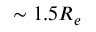<formula> <loc_0><loc_0><loc_500><loc_500>\sim 1 . 5 R _ { e }</formula> 